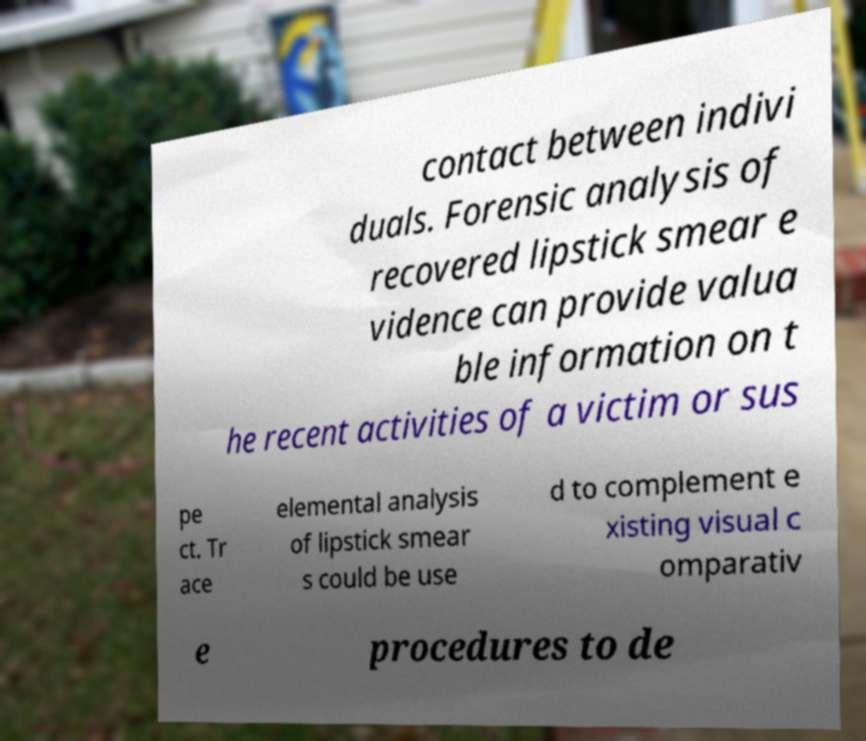There's text embedded in this image that I need extracted. Can you transcribe it verbatim? contact between indivi duals. Forensic analysis of recovered lipstick smear e vidence can provide valua ble information on t he recent activities of a victim or sus pe ct. Tr ace elemental analysis of lipstick smear s could be use d to complement e xisting visual c omparativ e procedures to de 